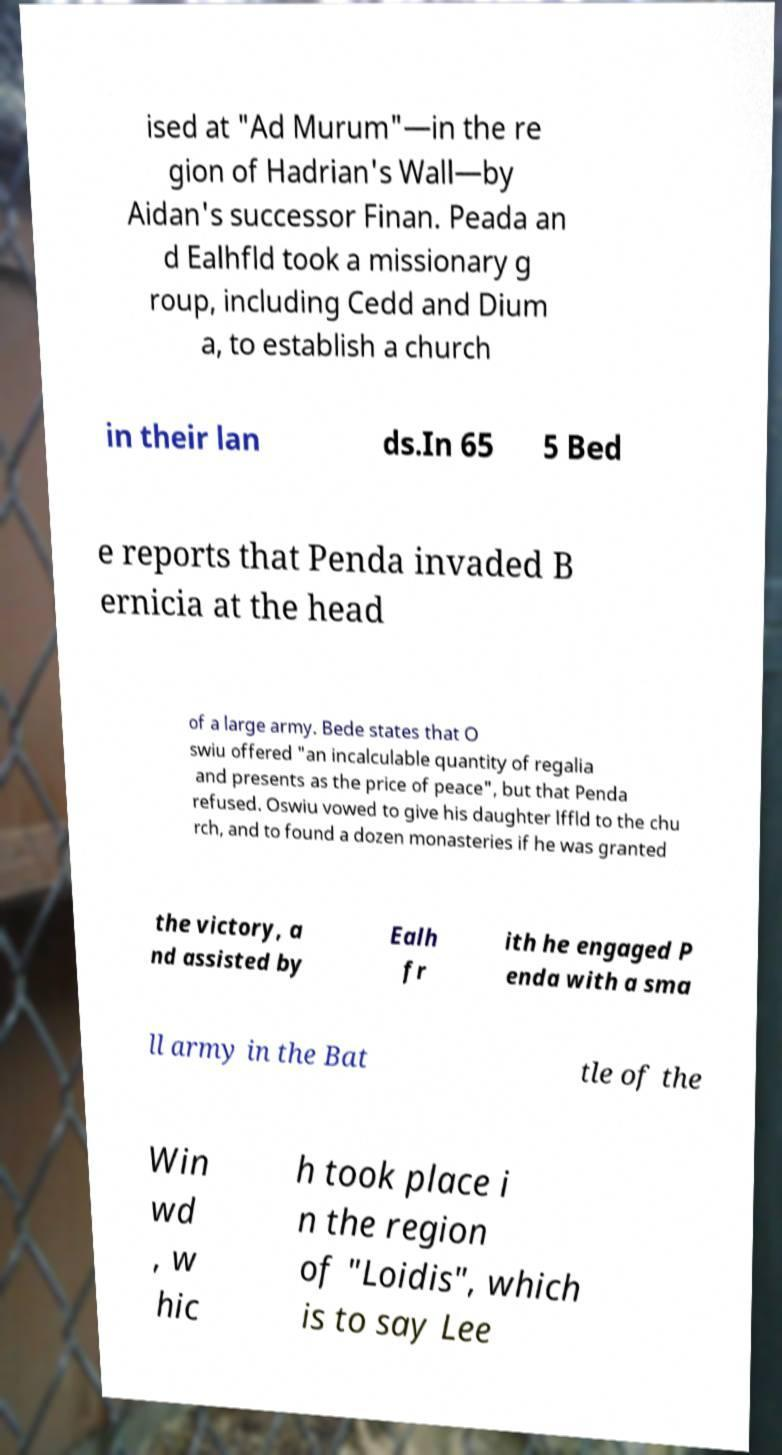Please read and relay the text visible in this image. What does it say? ised at "Ad Murum"—in the re gion of Hadrian's Wall—by Aidan's successor Finan. Peada an d Ealhfld took a missionary g roup, including Cedd and Dium a, to establish a church in their lan ds.In 65 5 Bed e reports that Penda invaded B ernicia at the head of a large army. Bede states that O swiu offered "an incalculable quantity of regalia and presents as the price of peace", but that Penda refused. Oswiu vowed to give his daughter lffld to the chu rch, and to found a dozen monasteries if he was granted the victory, a nd assisted by Ealh fr ith he engaged P enda with a sma ll army in the Bat tle of the Win wd , w hic h took place i n the region of "Loidis", which is to say Lee 